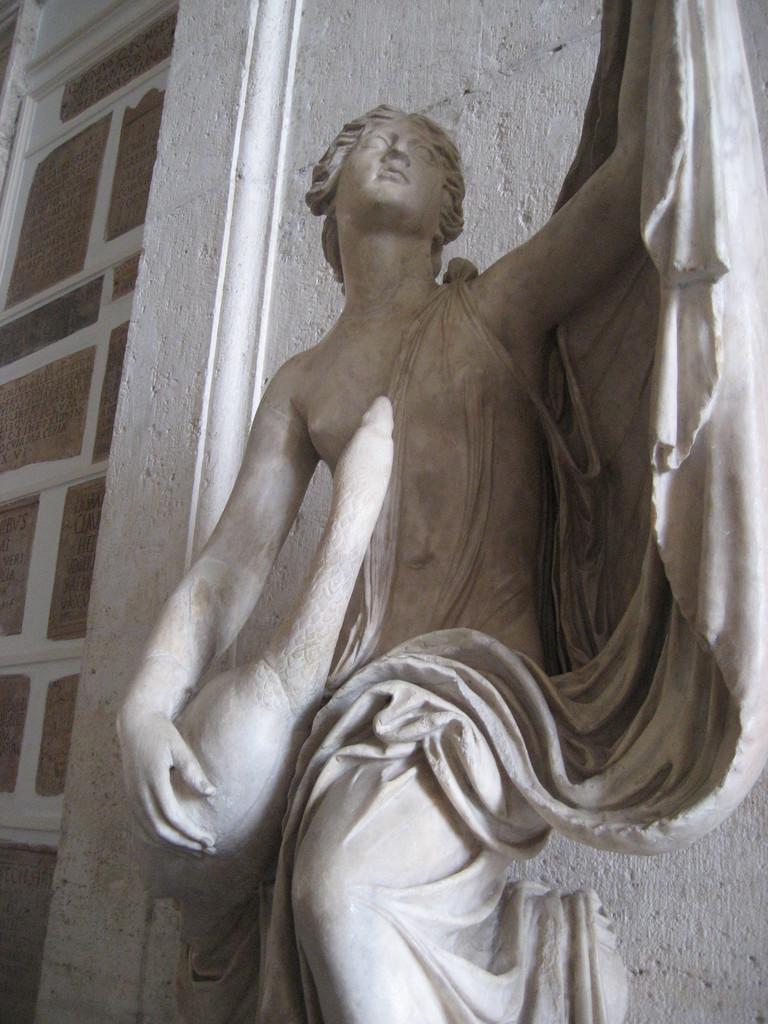Describe this image in one or two sentences. In this image, we can see a sculpture in front of the wall. 